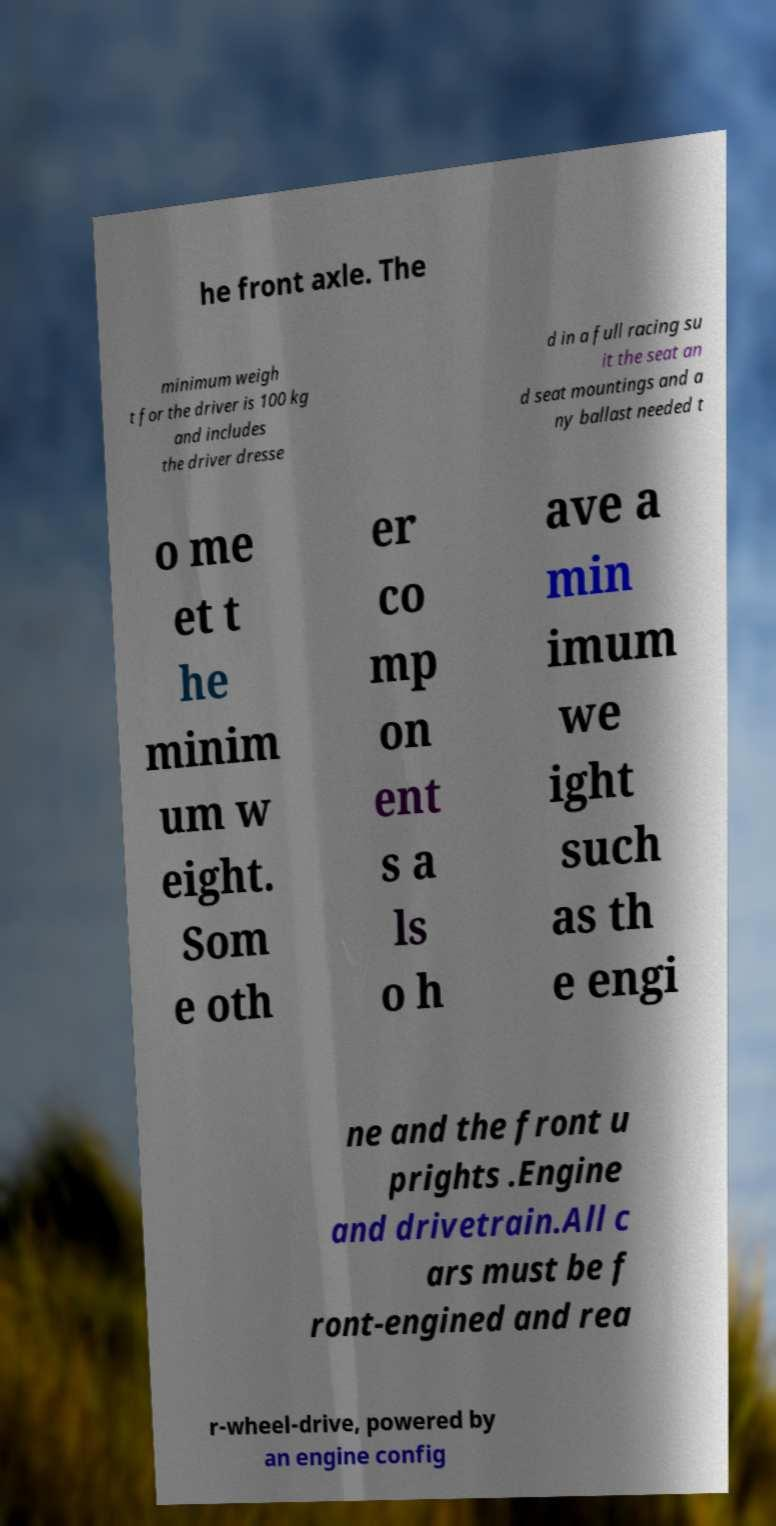Could you extract and type out the text from this image? he front axle. The minimum weigh t for the driver is 100 kg and includes the driver dresse d in a full racing su it the seat an d seat mountings and a ny ballast needed t o me et t he minim um w eight. Som e oth er co mp on ent s a ls o h ave a min imum we ight such as th e engi ne and the front u prights .Engine and drivetrain.All c ars must be f ront-engined and rea r-wheel-drive, powered by an engine config 